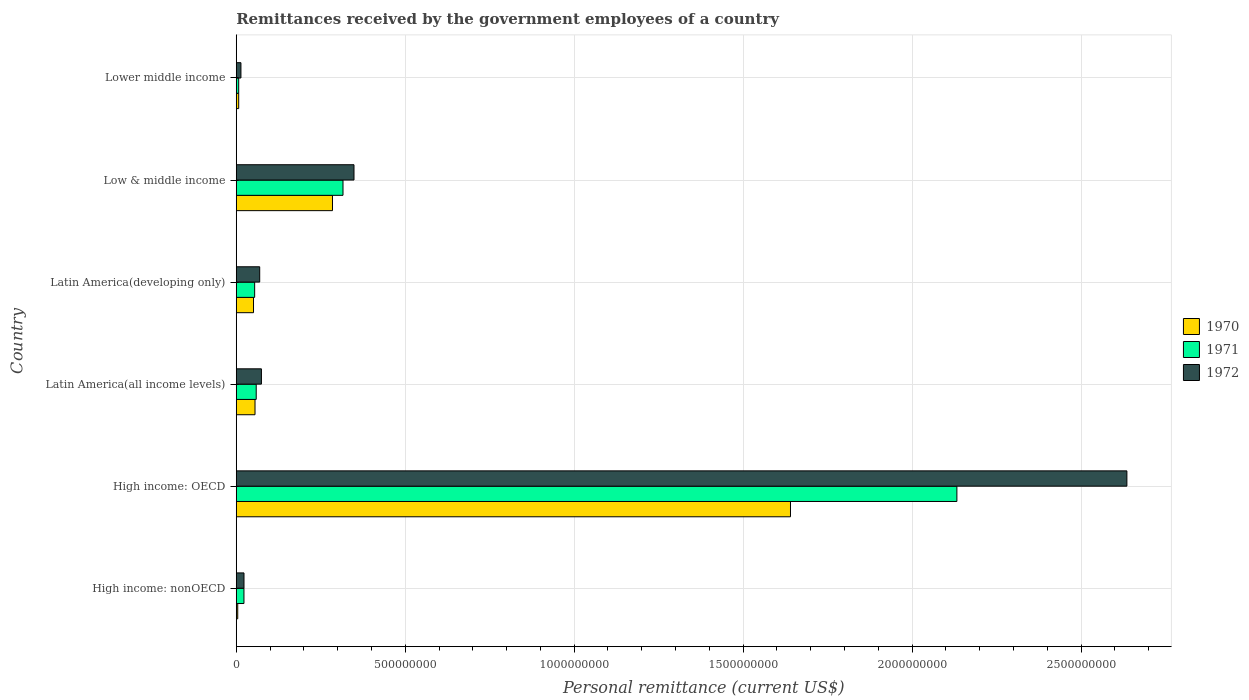How many different coloured bars are there?
Provide a short and direct response. 3. How many groups of bars are there?
Your answer should be compact. 6. Are the number of bars per tick equal to the number of legend labels?
Provide a short and direct response. Yes. Are the number of bars on each tick of the Y-axis equal?
Offer a very short reply. Yes. How many bars are there on the 1st tick from the top?
Give a very brief answer. 3. How many bars are there on the 5th tick from the bottom?
Provide a succinct answer. 3. What is the remittances received by the government employees in 1970 in Low & middle income?
Provide a succinct answer. 2.85e+08. Across all countries, what is the maximum remittances received by the government employees in 1970?
Offer a terse response. 1.64e+09. Across all countries, what is the minimum remittances received by the government employees in 1972?
Keep it short and to the point. 1.39e+07. In which country was the remittances received by the government employees in 1972 maximum?
Make the answer very short. High income: OECD. In which country was the remittances received by the government employees in 1970 minimum?
Your answer should be very brief. High income: nonOECD. What is the total remittances received by the government employees in 1971 in the graph?
Make the answer very short. 2.59e+09. What is the difference between the remittances received by the government employees in 1972 in High income: nonOECD and that in Low & middle income?
Your answer should be compact. -3.26e+08. What is the difference between the remittances received by the government employees in 1971 in Latin America(developing only) and the remittances received by the government employees in 1972 in Low & middle income?
Your answer should be compact. -2.94e+08. What is the average remittances received by the government employees in 1970 per country?
Provide a succinct answer. 3.41e+08. What is the difference between the remittances received by the government employees in 1972 and remittances received by the government employees in 1970 in Latin America(developing only)?
Your answer should be compact. 1.83e+07. In how many countries, is the remittances received by the government employees in 1972 greater than 1100000000 US$?
Provide a succinct answer. 1. What is the ratio of the remittances received by the government employees in 1971 in High income: nonOECD to that in Latin America(all income levels)?
Provide a succinct answer. 0.39. What is the difference between the highest and the second highest remittances received by the government employees in 1972?
Your answer should be compact. 2.29e+09. What is the difference between the highest and the lowest remittances received by the government employees in 1970?
Make the answer very short. 1.64e+09. In how many countries, is the remittances received by the government employees in 1972 greater than the average remittances received by the government employees in 1972 taken over all countries?
Make the answer very short. 1. How many bars are there?
Your answer should be very brief. 18. Are all the bars in the graph horizontal?
Offer a very short reply. Yes. What is the difference between two consecutive major ticks on the X-axis?
Provide a succinct answer. 5.00e+08. Does the graph contain grids?
Ensure brevity in your answer.  Yes. How many legend labels are there?
Your response must be concise. 3. What is the title of the graph?
Ensure brevity in your answer.  Remittances received by the government employees of a country. Does "1960" appear as one of the legend labels in the graph?
Provide a succinct answer. No. What is the label or title of the X-axis?
Your answer should be compact. Personal remittance (current US$). What is the label or title of the Y-axis?
Provide a short and direct response. Country. What is the Personal remittance (current US$) in 1970 in High income: nonOECD?
Provide a short and direct response. 4.40e+06. What is the Personal remittance (current US$) in 1971 in High income: nonOECD?
Provide a succinct answer. 2.28e+07. What is the Personal remittance (current US$) of 1972 in High income: nonOECD?
Make the answer very short. 2.29e+07. What is the Personal remittance (current US$) in 1970 in High income: OECD?
Your response must be concise. 1.64e+09. What is the Personal remittance (current US$) in 1971 in High income: OECD?
Ensure brevity in your answer.  2.13e+09. What is the Personal remittance (current US$) of 1972 in High income: OECD?
Your answer should be very brief. 2.64e+09. What is the Personal remittance (current US$) of 1970 in Latin America(all income levels)?
Offer a very short reply. 5.55e+07. What is the Personal remittance (current US$) of 1971 in Latin America(all income levels)?
Provide a short and direct response. 5.91e+07. What is the Personal remittance (current US$) of 1972 in Latin America(all income levels)?
Offer a terse response. 7.45e+07. What is the Personal remittance (current US$) of 1970 in Latin America(developing only)?
Provide a short and direct response. 5.11e+07. What is the Personal remittance (current US$) of 1971 in Latin America(developing only)?
Offer a very short reply. 5.45e+07. What is the Personal remittance (current US$) of 1972 in Latin America(developing only)?
Your answer should be compact. 6.94e+07. What is the Personal remittance (current US$) in 1970 in Low & middle income?
Provide a short and direct response. 2.85e+08. What is the Personal remittance (current US$) in 1971 in Low & middle income?
Keep it short and to the point. 3.16e+08. What is the Personal remittance (current US$) of 1972 in Low & middle income?
Offer a very short reply. 3.48e+08. What is the Personal remittance (current US$) of 1970 in Lower middle income?
Keep it short and to the point. 7.26e+06. What is the Personal remittance (current US$) in 1971 in Lower middle income?
Provide a succinct answer. 7.26e+06. What is the Personal remittance (current US$) in 1972 in Lower middle income?
Ensure brevity in your answer.  1.39e+07. Across all countries, what is the maximum Personal remittance (current US$) of 1970?
Your answer should be very brief. 1.64e+09. Across all countries, what is the maximum Personal remittance (current US$) in 1971?
Provide a succinct answer. 2.13e+09. Across all countries, what is the maximum Personal remittance (current US$) of 1972?
Your answer should be compact. 2.64e+09. Across all countries, what is the minimum Personal remittance (current US$) in 1970?
Keep it short and to the point. 4.40e+06. Across all countries, what is the minimum Personal remittance (current US$) in 1971?
Make the answer very short. 7.26e+06. Across all countries, what is the minimum Personal remittance (current US$) in 1972?
Your answer should be compact. 1.39e+07. What is the total Personal remittance (current US$) of 1970 in the graph?
Your response must be concise. 2.04e+09. What is the total Personal remittance (current US$) in 1971 in the graph?
Keep it short and to the point. 2.59e+09. What is the total Personal remittance (current US$) of 1972 in the graph?
Ensure brevity in your answer.  3.16e+09. What is the difference between the Personal remittance (current US$) of 1970 in High income: nonOECD and that in High income: OECD?
Give a very brief answer. -1.64e+09. What is the difference between the Personal remittance (current US$) in 1971 in High income: nonOECD and that in High income: OECD?
Give a very brief answer. -2.11e+09. What is the difference between the Personal remittance (current US$) in 1972 in High income: nonOECD and that in High income: OECD?
Provide a short and direct response. -2.61e+09. What is the difference between the Personal remittance (current US$) in 1970 in High income: nonOECD and that in Latin America(all income levels)?
Keep it short and to the point. -5.11e+07. What is the difference between the Personal remittance (current US$) in 1971 in High income: nonOECD and that in Latin America(all income levels)?
Offer a terse response. -3.63e+07. What is the difference between the Personal remittance (current US$) of 1972 in High income: nonOECD and that in Latin America(all income levels)?
Provide a short and direct response. -5.16e+07. What is the difference between the Personal remittance (current US$) in 1970 in High income: nonOECD and that in Latin America(developing only)?
Offer a terse response. -4.67e+07. What is the difference between the Personal remittance (current US$) in 1971 in High income: nonOECD and that in Latin America(developing only)?
Provide a short and direct response. -3.17e+07. What is the difference between the Personal remittance (current US$) in 1972 in High income: nonOECD and that in Latin America(developing only)?
Ensure brevity in your answer.  -4.65e+07. What is the difference between the Personal remittance (current US$) in 1970 in High income: nonOECD and that in Low & middle income?
Offer a very short reply. -2.80e+08. What is the difference between the Personal remittance (current US$) of 1971 in High income: nonOECD and that in Low & middle income?
Provide a succinct answer. -2.93e+08. What is the difference between the Personal remittance (current US$) in 1972 in High income: nonOECD and that in Low & middle income?
Offer a very short reply. -3.26e+08. What is the difference between the Personal remittance (current US$) of 1970 in High income: nonOECD and that in Lower middle income?
Your response must be concise. -2.86e+06. What is the difference between the Personal remittance (current US$) in 1971 in High income: nonOECD and that in Lower middle income?
Offer a terse response. 1.55e+07. What is the difference between the Personal remittance (current US$) of 1972 in High income: nonOECD and that in Lower middle income?
Give a very brief answer. 9.06e+06. What is the difference between the Personal remittance (current US$) in 1970 in High income: OECD and that in Latin America(all income levels)?
Offer a terse response. 1.58e+09. What is the difference between the Personal remittance (current US$) in 1971 in High income: OECD and that in Latin America(all income levels)?
Make the answer very short. 2.07e+09. What is the difference between the Personal remittance (current US$) of 1972 in High income: OECD and that in Latin America(all income levels)?
Make the answer very short. 2.56e+09. What is the difference between the Personal remittance (current US$) of 1970 in High income: OECD and that in Latin America(developing only)?
Ensure brevity in your answer.  1.59e+09. What is the difference between the Personal remittance (current US$) of 1971 in High income: OECD and that in Latin America(developing only)?
Ensure brevity in your answer.  2.08e+09. What is the difference between the Personal remittance (current US$) of 1972 in High income: OECD and that in Latin America(developing only)?
Make the answer very short. 2.57e+09. What is the difference between the Personal remittance (current US$) of 1970 in High income: OECD and that in Low & middle income?
Your response must be concise. 1.36e+09. What is the difference between the Personal remittance (current US$) of 1971 in High income: OECD and that in Low & middle income?
Keep it short and to the point. 1.82e+09. What is the difference between the Personal remittance (current US$) in 1972 in High income: OECD and that in Low & middle income?
Your answer should be compact. 2.29e+09. What is the difference between the Personal remittance (current US$) in 1970 in High income: OECD and that in Lower middle income?
Provide a succinct answer. 1.63e+09. What is the difference between the Personal remittance (current US$) of 1971 in High income: OECD and that in Lower middle income?
Your answer should be very brief. 2.13e+09. What is the difference between the Personal remittance (current US$) of 1972 in High income: OECD and that in Lower middle income?
Ensure brevity in your answer.  2.62e+09. What is the difference between the Personal remittance (current US$) in 1970 in Latin America(all income levels) and that in Latin America(developing only)?
Make the answer very short. 4.40e+06. What is the difference between the Personal remittance (current US$) of 1971 in Latin America(all income levels) and that in Latin America(developing only)?
Provide a short and direct response. 4.61e+06. What is the difference between the Personal remittance (current US$) in 1972 in Latin America(all income levels) and that in Latin America(developing only)?
Your answer should be compact. 5.10e+06. What is the difference between the Personal remittance (current US$) of 1970 in Latin America(all income levels) and that in Low & middle income?
Your response must be concise. -2.29e+08. What is the difference between the Personal remittance (current US$) of 1971 in Latin America(all income levels) and that in Low & middle income?
Keep it short and to the point. -2.57e+08. What is the difference between the Personal remittance (current US$) of 1972 in Latin America(all income levels) and that in Low & middle income?
Give a very brief answer. -2.74e+08. What is the difference between the Personal remittance (current US$) of 1970 in Latin America(all income levels) and that in Lower middle income?
Provide a short and direct response. 4.82e+07. What is the difference between the Personal remittance (current US$) in 1971 in Latin America(all income levels) and that in Lower middle income?
Offer a very short reply. 5.18e+07. What is the difference between the Personal remittance (current US$) in 1972 in Latin America(all income levels) and that in Lower middle income?
Your answer should be very brief. 6.06e+07. What is the difference between the Personal remittance (current US$) in 1970 in Latin America(developing only) and that in Low & middle income?
Make the answer very short. -2.34e+08. What is the difference between the Personal remittance (current US$) in 1971 in Latin America(developing only) and that in Low & middle income?
Ensure brevity in your answer.  -2.61e+08. What is the difference between the Personal remittance (current US$) of 1972 in Latin America(developing only) and that in Low & middle income?
Give a very brief answer. -2.79e+08. What is the difference between the Personal remittance (current US$) in 1970 in Latin America(developing only) and that in Lower middle income?
Your answer should be compact. 4.38e+07. What is the difference between the Personal remittance (current US$) in 1971 in Latin America(developing only) and that in Lower middle income?
Provide a short and direct response. 4.72e+07. What is the difference between the Personal remittance (current US$) of 1972 in Latin America(developing only) and that in Lower middle income?
Offer a terse response. 5.55e+07. What is the difference between the Personal remittance (current US$) of 1970 in Low & middle income and that in Lower middle income?
Offer a very short reply. 2.77e+08. What is the difference between the Personal remittance (current US$) in 1971 in Low & middle income and that in Lower middle income?
Give a very brief answer. 3.09e+08. What is the difference between the Personal remittance (current US$) of 1972 in Low & middle income and that in Lower middle income?
Ensure brevity in your answer.  3.35e+08. What is the difference between the Personal remittance (current US$) in 1970 in High income: nonOECD and the Personal remittance (current US$) in 1971 in High income: OECD?
Ensure brevity in your answer.  -2.13e+09. What is the difference between the Personal remittance (current US$) in 1970 in High income: nonOECD and the Personal remittance (current US$) in 1972 in High income: OECD?
Give a very brief answer. -2.63e+09. What is the difference between the Personal remittance (current US$) in 1971 in High income: nonOECD and the Personal remittance (current US$) in 1972 in High income: OECD?
Offer a very short reply. -2.61e+09. What is the difference between the Personal remittance (current US$) in 1970 in High income: nonOECD and the Personal remittance (current US$) in 1971 in Latin America(all income levels)?
Give a very brief answer. -5.47e+07. What is the difference between the Personal remittance (current US$) of 1970 in High income: nonOECD and the Personal remittance (current US$) of 1972 in Latin America(all income levels)?
Make the answer very short. -7.01e+07. What is the difference between the Personal remittance (current US$) of 1971 in High income: nonOECD and the Personal remittance (current US$) of 1972 in Latin America(all income levels)?
Ensure brevity in your answer.  -5.17e+07. What is the difference between the Personal remittance (current US$) in 1970 in High income: nonOECD and the Personal remittance (current US$) in 1971 in Latin America(developing only)?
Offer a very short reply. -5.01e+07. What is the difference between the Personal remittance (current US$) in 1970 in High income: nonOECD and the Personal remittance (current US$) in 1972 in Latin America(developing only)?
Keep it short and to the point. -6.50e+07. What is the difference between the Personal remittance (current US$) in 1971 in High income: nonOECD and the Personal remittance (current US$) in 1972 in Latin America(developing only)?
Your response must be concise. -4.66e+07. What is the difference between the Personal remittance (current US$) of 1970 in High income: nonOECD and the Personal remittance (current US$) of 1971 in Low & middle income?
Keep it short and to the point. -3.11e+08. What is the difference between the Personal remittance (current US$) of 1970 in High income: nonOECD and the Personal remittance (current US$) of 1972 in Low & middle income?
Provide a succinct answer. -3.44e+08. What is the difference between the Personal remittance (current US$) in 1971 in High income: nonOECD and the Personal remittance (current US$) in 1972 in Low & middle income?
Provide a short and direct response. -3.26e+08. What is the difference between the Personal remittance (current US$) in 1970 in High income: nonOECD and the Personal remittance (current US$) in 1971 in Lower middle income?
Provide a succinct answer. -2.86e+06. What is the difference between the Personal remittance (current US$) in 1970 in High income: nonOECD and the Personal remittance (current US$) in 1972 in Lower middle income?
Make the answer very short. -9.46e+06. What is the difference between the Personal remittance (current US$) of 1971 in High income: nonOECD and the Personal remittance (current US$) of 1972 in Lower middle income?
Your response must be concise. 8.92e+06. What is the difference between the Personal remittance (current US$) in 1970 in High income: OECD and the Personal remittance (current US$) in 1971 in Latin America(all income levels)?
Offer a very short reply. 1.58e+09. What is the difference between the Personal remittance (current US$) in 1970 in High income: OECD and the Personal remittance (current US$) in 1972 in Latin America(all income levels)?
Your answer should be compact. 1.57e+09. What is the difference between the Personal remittance (current US$) of 1971 in High income: OECD and the Personal remittance (current US$) of 1972 in Latin America(all income levels)?
Give a very brief answer. 2.06e+09. What is the difference between the Personal remittance (current US$) of 1970 in High income: OECD and the Personal remittance (current US$) of 1971 in Latin America(developing only)?
Your response must be concise. 1.59e+09. What is the difference between the Personal remittance (current US$) in 1970 in High income: OECD and the Personal remittance (current US$) in 1972 in Latin America(developing only)?
Ensure brevity in your answer.  1.57e+09. What is the difference between the Personal remittance (current US$) of 1971 in High income: OECD and the Personal remittance (current US$) of 1972 in Latin America(developing only)?
Ensure brevity in your answer.  2.06e+09. What is the difference between the Personal remittance (current US$) of 1970 in High income: OECD and the Personal remittance (current US$) of 1971 in Low & middle income?
Keep it short and to the point. 1.32e+09. What is the difference between the Personal remittance (current US$) in 1970 in High income: OECD and the Personal remittance (current US$) in 1972 in Low & middle income?
Offer a very short reply. 1.29e+09. What is the difference between the Personal remittance (current US$) of 1971 in High income: OECD and the Personal remittance (current US$) of 1972 in Low & middle income?
Offer a terse response. 1.78e+09. What is the difference between the Personal remittance (current US$) of 1970 in High income: OECD and the Personal remittance (current US$) of 1971 in Lower middle income?
Provide a succinct answer. 1.63e+09. What is the difference between the Personal remittance (current US$) in 1970 in High income: OECD and the Personal remittance (current US$) in 1972 in Lower middle income?
Make the answer very short. 1.63e+09. What is the difference between the Personal remittance (current US$) in 1971 in High income: OECD and the Personal remittance (current US$) in 1972 in Lower middle income?
Your answer should be very brief. 2.12e+09. What is the difference between the Personal remittance (current US$) of 1970 in Latin America(all income levels) and the Personal remittance (current US$) of 1971 in Latin America(developing only)?
Give a very brief answer. 1.03e+06. What is the difference between the Personal remittance (current US$) in 1970 in Latin America(all income levels) and the Personal remittance (current US$) in 1972 in Latin America(developing only)?
Your answer should be compact. -1.39e+07. What is the difference between the Personal remittance (current US$) of 1971 in Latin America(all income levels) and the Personal remittance (current US$) of 1972 in Latin America(developing only)?
Offer a very short reply. -1.03e+07. What is the difference between the Personal remittance (current US$) in 1970 in Latin America(all income levels) and the Personal remittance (current US$) in 1971 in Low & middle income?
Give a very brief answer. -2.60e+08. What is the difference between the Personal remittance (current US$) in 1970 in Latin America(all income levels) and the Personal remittance (current US$) in 1972 in Low & middle income?
Your response must be concise. -2.93e+08. What is the difference between the Personal remittance (current US$) in 1971 in Latin America(all income levels) and the Personal remittance (current US$) in 1972 in Low & middle income?
Offer a very short reply. -2.89e+08. What is the difference between the Personal remittance (current US$) of 1970 in Latin America(all income levels) and the Personal remittance (current US$) of 1971 in Lower middle income?
Provide a succinct answer. 4.82e+07. What is the difference between the Personal remittance (current US$) in 1970 in Latin America(all income levels) and the Personal remittance (current US$) in 1972 in Lower middle income?
Give a very brief answer. 4.16e+07. What is the difference between the Personal remittance (current US$) in 1971 in Latin America(all income levels) and the Personal remittance (current US$) in 1972 in Lower middle income?
Provide a short and direct response. 4.52e+07. What is the difference between the Personal remittance (current US$) of 1970 in Latin America(developing only) and the Personal remittance (current US$) of 1971 in Low & middle income?
Give a very brief answer. -2.65e+08. What is the difference between the Personal remittance (current US$) of 1970 in Latin America(developing only) and the Personal remittance (current US$) of 1972 in Low & middle income?
Keep it short and to the point. -2.97e+08. What is the difference between the Personal remittance (current US$) in 1971 in Latin America(developing only) and the Personal remittance (current US$) in 1972 in Low & middle income?
Your answer should be compact. -2.94e+08. What is the difference between the Personal remittance (current US$) of 1970 in Latin America(developing only) and the Personal remittance (current US$) of 1971 in Lower middle income?
Ensure brevity in your answer.  4.38e+07. What is the difference between the Personal remittance (current US$) in 1970 in Latin America(developing only) and the Personal remittance (current US$) in 1972 in Lower middle income?
Offer a very short reply. 3.72e+07. What is the difference between the Personal remittance (current US$) in 1971 in Latin America(developing only) and the Personal remittance (current US$) in 1972 in Lower middle income?
Make the answer very short. 4.06e+07. What is the difference between the Personal remittance (current US$) in 1970 in Low & middle income and the Personal remittance (current US$) in 1971 in Lower middle income?
Give a very brief answer. 2.77e+08. What is the difference between the Personal remittance (current US$) in 1970 in Low & middle income and the Personal remittance (current US$) in 1972 in Lower middle income?
Keep it short and to the point. 2.71e+08. What is the difference between the Personal remittance (current US$) of 1971 in Low & middle income and the Personal remittance (current US$) of 1972 in Lower middle income?
Give a very brief answer. 3.02e+08. What is the average Personal remittance (current US$) of 1970 per country?
Provide a short and direct response. 3.41e+08. What is the average Personal remittance (current US$) in 1971 per country?
Your answer should be compact. 4.32e+08. What is the average Personal remittance (current US$) in 1972 per country?
Give a very brief answer. 5.27e+08. What is the difference between the Personal remittance (current US$) of 1970 and Personal remittance (current US$) of 1971 in High income: nonOECD?
Give a very brief answer. -1.84e+07. What is the difference between the Personal remittance (current US$) in 1970 and Personal remittance (current US$) in 1972 in High income: nonOECD?
Your answer should be compact. -1.85e+07. What is the difference between the Personal remittance (current US$) of 1971 and Personal remittance (current US$) of 1972 in High income: nonOECD?
Keep it short and to the point. -1.37e+05. What is the difference between the Personal remittance (current US$) of 1970 and Personal remittance (current US$) of 1971 in High income: OECD?
Offer a terse response. -4.92e+08. What is the difference between the Personal remittance (current US$) in 1970 and Personal remittance (current US$) in 1972 in High income: OECD?
Offer a very short reply. -9.96e+08. What is the difference between the Personal remittance (current US$) of 1971 and Personal remittance (current US$) of 1972 in High income: OECD?
Give a very brief answer. -5.03e+08. What is the difference between the Personal remittance (current US$) of 1970 and Personal remittance (current US$) of 1971 in Latin America(all income levels)?
Offer a terse response. -3.57e+06. What is the difference between the Personal remittance (current US$) of 1970 and Personal remittance (current US$) of 1972 in Latin America(all income levels)?
Offer a terse response. -1.90e+07. What is the difference between the Personal remittance (current US$) of 1971 and Personal remittance (current US$) of 1972 in Latin America(all income levels)?
Your response must be concise. -1.54e+07. What is the difference between the Personal remittance (current US$) of 1970 and Personal remittance (current US$) of 1971 in Latin America(developing only)?
Offer a very short reply. -3.37e+06. What is the difference between the Personal remittance (current US$) in 1970 and Personal remittance (current US$) in 1972 in Latin America(developing only)?
Offer a very short reply. -1.83e+07. What is the difference between the Personal remittance (current US$) of 1971 and Personal remittance (current US$) of 1972 in Latin America(developing only)?
Give a very brief answer. -1.49e+07. What is the difference between the Personal remittance (current US$) in 1970 and Personal remittance (current US$) in 1971 in Low & middle income?
Offer a terse response. -3.11e+07. What is the difference between the Personal remittance (current US$) in 1970 and Personal remittance (current US$) in 1972 in Low & middle income?
Ensure brevity in your answer.  -6.37e+07. What is the difference between the Personal remittance (current US$) of 1971 and Personal remittance (current US$) of 1972 in Low & middle income?
Offer a very short reply. -3.25e+07. What is the difference between the Personal remittance (current US$) in 1970 and Personal remittance (current US$) in 1972 in Lower middle income?
Give a very brief answer. -6.60e+06. What is the difference between the Personal remittance (current US$) of 1971 and Personal remittance (current US$) of 1972 in Lower middle income?
Your answer should be very brief. -6.60e+06. What is the ratio of the Personal remittance (current US$) in 1970 in High income: nonOECD to that in High income: OECD?
Offer a terse response. 0. What is the ratio of the Personal remittance (current US$) of 1971 in High income: nonOECD to that in High income: OECD?
Your answer should be compact. 0.01. What is the ratio of the Personal remittance (current US$) of 1972 in High income: nonOECD to that in High income: OECD?
Give a very brief answer. 0.01. What is the ratio of the Personal remittance (current US$) in 1970 in High income: nonOECD to that in Latin America(all income levels)?
Your response must be concise. 0.08. What is the ratio of the Personal remittance (current US$) in 1971 in High income: nonOECD to that in Latin America(all income levels)?
Provide a short and direct response. 0.39. What is the ratio of the Personal remittance (current US$) in 1972 in High income: nonOECD to that in Latin America(all income levels)?
Your response must be concise. 0.31. What is the ratio of the Personal remittance (current US$) in 1970 in High income: nonOECD to that in Latin America(developing only)?
Your response must be concise. 0.09. What is the ratio of the Personal remittance (current US$) of 1971 in High income: nonOECD to that in Latin America(developing only)?
Provide a succinct answer. 0.42. What is the ratio of the Personal remittance (current US$) in 1972 in High income: nonOECD to that in Latin America(developing only)?
Offer a very short reply. 0.33. What is the ratio of the Personal remittance (current US$) in 1970 in High income: nonOECD to that in Low & middle income?
Ensure brevity in your answer.  0.02. What is the ratio of the Personal remittance (current US$) in 1971 in High income: nonOECD to that in Low & middle income?
Your response must be concise. 0.07. What is the ratio of the Personal remittance (current US$) of 1972 in High income: nonOECD to that in Low & middle income?
Offer a terse response. 0.07. What is the ratio of the Personal remittance (current US$) of 1970 in High income: nonOECD to that in Lower middle income?
Give a very brief answer. 0.61. What is the ratio of the Personal remittance (current US$) of 1971 in High income: nonOECD to that in Lower middle income?
Provide a short and direct response. 3.14. What is the ratio of the Personal remittance (current US$) in 1972 in High income: nonOECD to that in Lower middle income?
Your answer should be very brief. 1.65. What is the ratio of the Personal remittance (current US$) of 1970 in High income: OECD to that in Latin America(all income levels)?
Give a very brief answer. 29.55. What is the ratio of the Personal remittance (current US$) in 1971 in High income: OECD to that in Latin America(all income levels)?
Your answer should be very brief. 36.1. What is the ratio of the Personal remittance (current US$) of 1972 in High income: OECD to that in Latin America(all income levels)?
Give a very brief answer. 35.39. What is the ratio of the Personal remittance (current US$) in 1970 in High income: OECD to that in Latin America(developing only)?
Provide a short and direct response. 32.1. What is the ratio of the Personal remittance (current US$) in 1971 in High income: OECD to that in Latin America(developing only)?
Make the answer very short. 39.15. What is the ratio of the Personal remittance (current US$) of 1972 in High income: OECD to that in Latin America(developing only)?
Ensure brevity in your answer.  37.99. What is the ratio of the Personal remittance (current US$) in 1970 in High income: OECD to that in Low & middle income?
Provide a succinct answer. 5.76. What is the ratio of the Personal remittance (current US$) of 1971 in High income: OECD to that in Low & middle income?
Offer a very short reply. 6.75. What is the ratio of the Personal remittance (current US$) in 1972 in High income: OECD to that in Low & middle income?
Keep it short and to the point. 7.56. What is the ratio of the Personal remittance (current US$) of 1970 in High income: OECD to that in Lower middle income?
Give a very brief answer. 225.91. What is the ratio of the Personal remittance (current US$) of 1971 in High income: OECD to that in Lower middle income?
Ensure brevity in your answer.  293.74. What is the ratio of the Personal remittance (current US$) of 1972 in High income: OECD to that in Lower middle income?
Offer a terse response. 190.16. What is the ratio of the Personal remittance (current US$) in 1970 in Latin America(all income levels) to that in Latin America(developing only)?
Your answer should be compact. 1.09. What is the ratio of the Personal remittance (current US$) of 1971 in Latin America(all income levels) to that in Latin America(developing only)?
Ensure brevity in your answer.  1.08. What is the ratio of the Personal remittance (current US$) of 1972 in Latin America(all income levels) to that in Latin America(developing only)?
Your response must be concise. 1.07. What is the ratio of the Personal remittance (current US$) in 1970 in Latin America(all income levels) to that in Low & middle income?
Ensure brevity in your answer.  0.19. What is the ratio of the Personal remittance (current US$) of 1971 in Latin America(all income levels) to that in Low & middle income?
Make the answer very short. 0.19. What is the ratio of the Personal remittance (current US$) in 1972 in Latin America(all income levels) to that in Low & middle income?
Provide a succinct answer. 0.21. What is the ratio of the Personal remittance (current US$) in 1970 in Latin America(all income levels) to that in Lower middle income?
Your answer should be very brief. 7.64. What is the ratio of the Personal remittance (current US$) of 1971 in Latin America(all income levels) to that in Lower middle income?
Provide a succinct answer. 8.14. What is the ratio of the Personal remittance (current US$) of 1972 in Latin America(all income levels) to that in Lower middle income?
Keep it short and to the point. 5.37. What is the ratio of the Personal remittance (current US$) of 1970 in Latin America(developing only) to that in Low & middle income?
Provide a short and direct response. 0.18. What is the ratio of the Personal remittance (current US$) in 1971 in Latin America(developing only) to that in Low & middle income?
Your answer should be very brief. 0.17. What is the ratio of the Personal remittance (current US$) in 1972 in Latin America(developing only) to that in Low & middle income?
Provide a succinct answer. 0.2. What is the ratio of the Personal remittance (current US$) of 1970 in Latin America(developing only) to that in Lower middle income?
Ensure brevity in your answer.  7.04. What is the ratio of the Personal remittance (current US$) in 1971 in Latin America(developing only) to that in Lower middle income?
Offer a terse response. 7.5. What is the ratio of the Personal remittance (current US$) in 1972 in Latin America(developing only) to that in Lower middle income?
Provide a succinct answer. 5.01. What is the ratio of the Personal remittance (current US$) in 1970 in Low & middle income to that in Lower middle income?
Offer a terse response. 39.22. What is the ratio of the Personal remittance (current US$) of 1971 in Low & middle income to that in Lower middle income?
Offer a terse response. 43.51. What is the ratio of the Personal remittance (current US$) in 1972 in Low & middle income to that in Lower middle income?
Give a very brief answer. 25.14. What is the difference between the highest and the second highest Personal remittance (current US$) in 1970?
Your response must be concise. 1.36e+09. What is the difference between the highest and the second highest Personal remittance (current US$) in 1971?
Your answer should be compact. 1.82e+09. What is the difference between the highest and the second highest Personal remittance (current US$) of 1972?
Provide a succinct answer. 2.29e+09. What is the difference between the highest and the lowest Personal remittance (current US$) of 1970?
Your answer should be very brief. 1.64e+09. What is the difference between the highest and the lowest Personal remittance (current US$) in 1971?
Ensure brevity in your answer.  2.13e+09. What is the difference between the highest and the lowest Personal remittance (current US$) in 1972?
Offer a very short reply. 2.62e+09. 